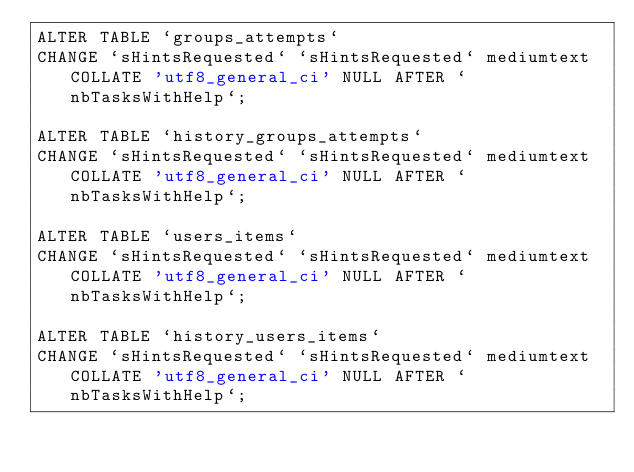<code> <loc_0><loc_0><loc_500><loc_500><_SQL_>ALTER TABLE `groups_attempts`
CHANGE `sHintsRequested` `sHintsRequested` mediumtext COLLATE 'utf8_general_ci' NULL AFTER `nbTasksWithHelp`;

ALTER TABLE `history_groups_attempts`
CHANGE `sHintsRequested` `sHintsRequested` mediumtext COLLATE 'utf8_general_ci' NULL AFTER `nbTasksWithHelp`;

ALTER TABLE `users_items`
CHANGE `sHintsRequested` `sHintsRequested` mediumtext COLLATE 'utf8_general_ci' NULL AFTER `nbTasksWithHelp`;

ALTER TABLE `history_users_items`
CHANGE `sHintsRequested` `sHintsRequested` mediumtext COLLATE 'utf8_general_ci' NULL AFTER `nbTasksWithHelp`;</code> 